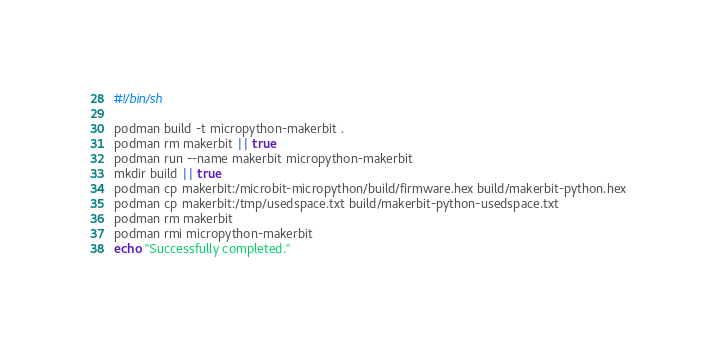<code> <loc_0><loc_0><loc_500><loc_500><_Bash_>#!/bin/sh

podman build -t micropython-makerbit .
podman rm makerbit || true
podman run --name makerbit micropython-makerbit
mkdir build || true
podman cp makerbit:/microbit-micropython/build/firmware.hex build/makerbit-python.hex
podman cp makerbit:/tmp/usedspace.txt build/makerbit-python-usedspace.txt
podman rm makerbit
podman rmi micropython-makerbit
echo "Successfully completed."
</code> 